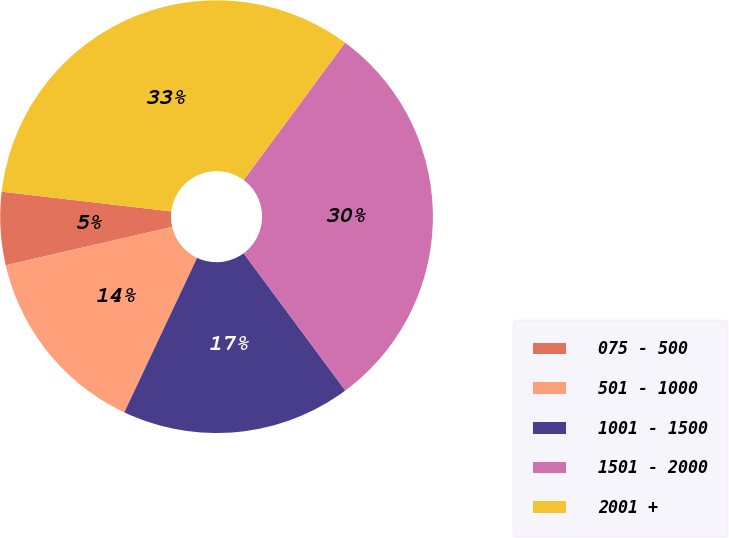Convert chart. <chart><loc_0><loc_0><loc_500><loc_500><pie_chart><fcel>075 - 500<fcel>501 - 1000<fcel>1001 - 1500<fcel>1501 - 2000<fcel>2001 +<nl><fcel>5.45%<fcel>14.38%<fcel>17.16%<fcel>29.73%<fcel>33.28%<nl></chart> 